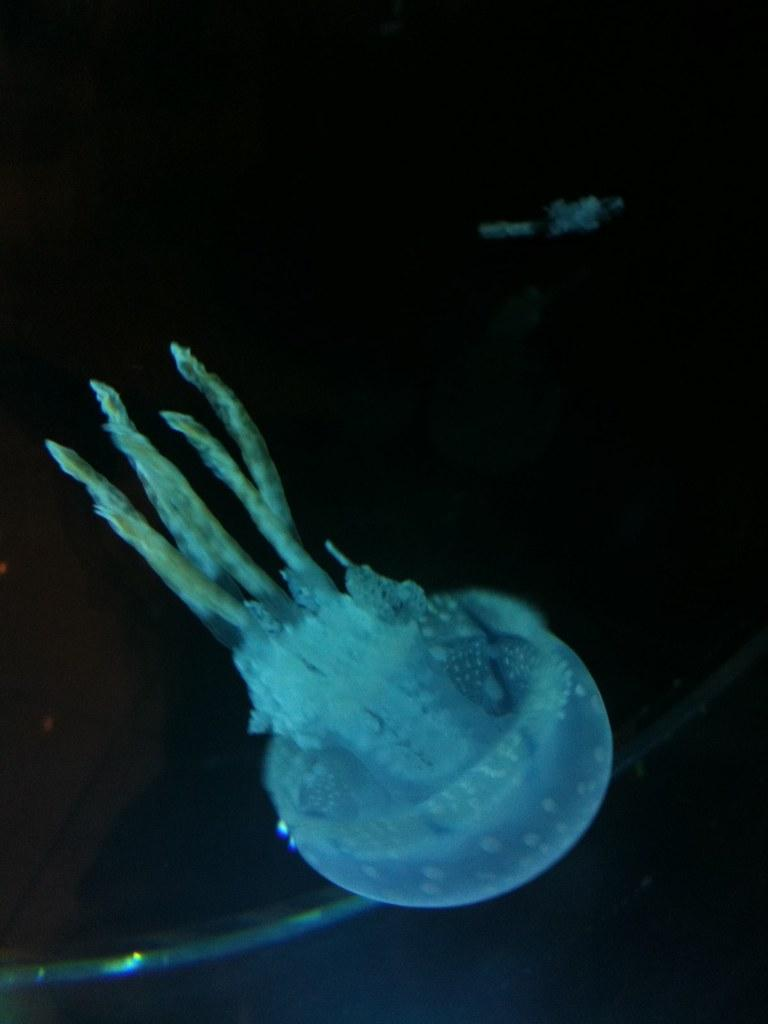What is the main subject of the image? There is a jellyfish in the image. What color is the background of the image? The background of the image is black. How many tickets are visible in the image? There are no tickets present in the image. What type of pump is used by the jellyfish in the image? There is no pump present in the image, as it features a jellyfish in a black background. 